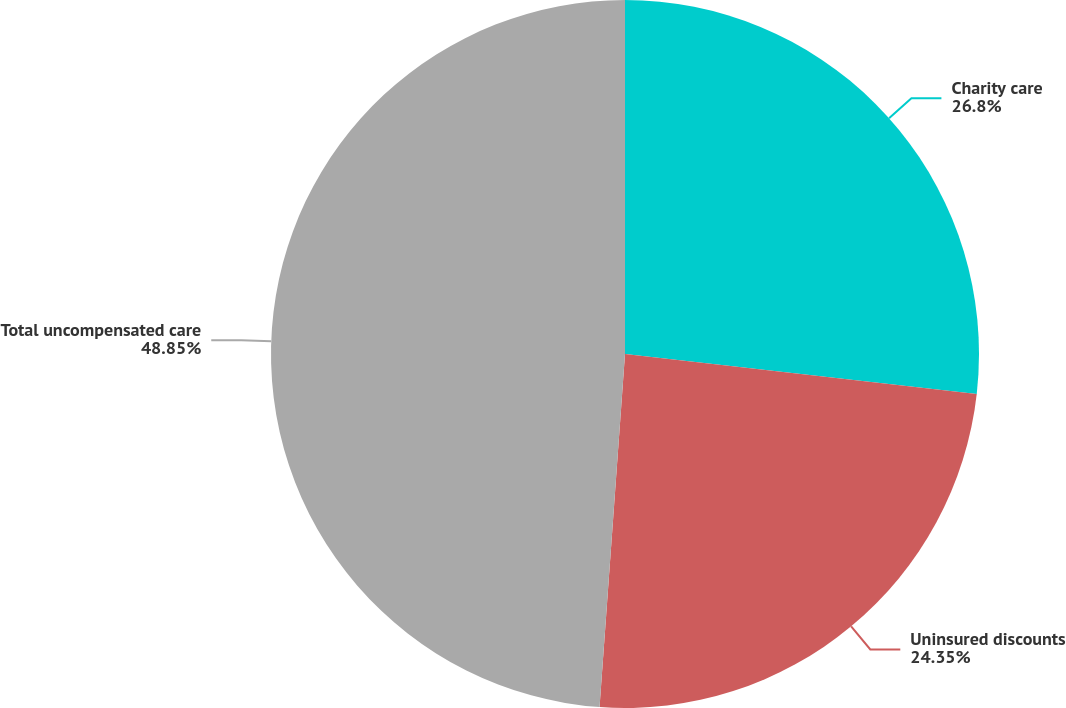<chart> <loc_0><loc_0><loc_500><loc_500><pie_chart><fcel>Charity care<fcel>Uninsured discounts<fcel>Total uncompensated care<nl><fcel>26.8%<fcel>24.35%<fcel>48.86%<nl></chart> 